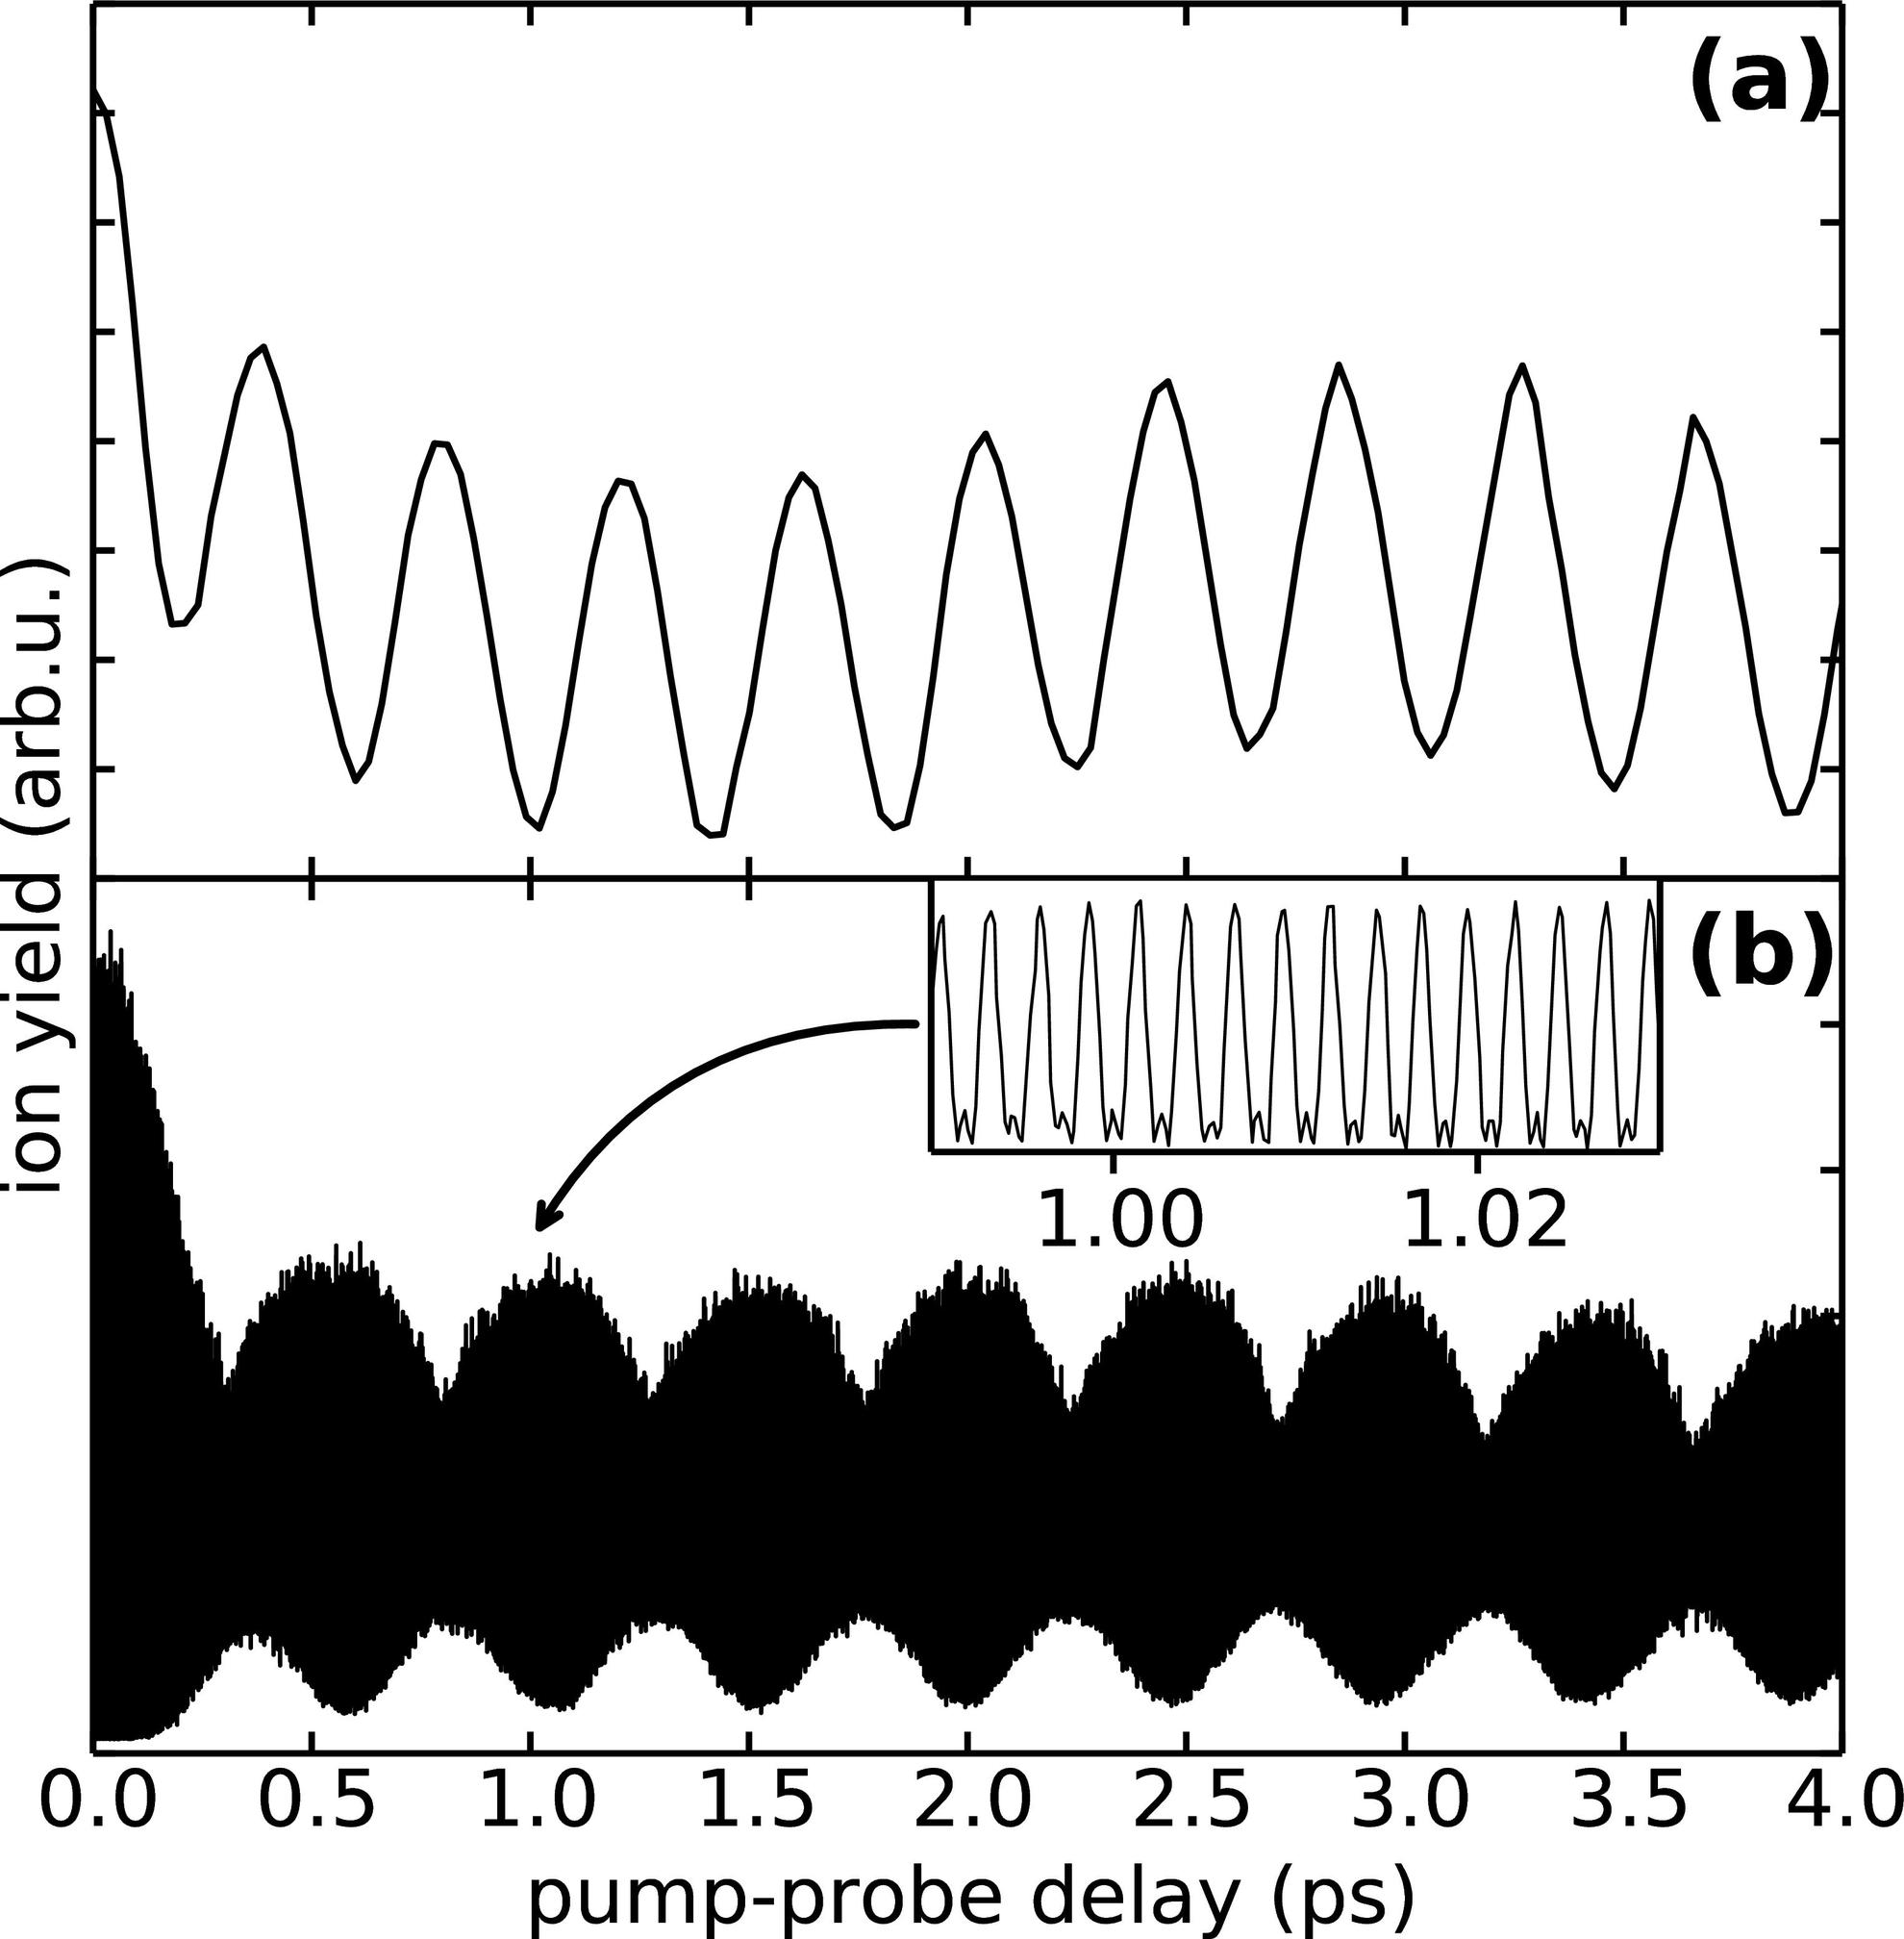What does the inset in panel (b) of the figure highlight? The inset in panel (b) of the figure magnifies a critical section of the graph between 1.00 to 1.02 ps pump-probe delay, showcasing an oscillatory pattern. These detailed oscillations correspond closely with the broader trends observed in the main graph, emphasizing the repeatability and potential resonant phenomena under investigation. This closer view aids in distinguishing finer aspects of the data, which may be critical for drawing conclusions about the interaction dynamics being studied. 